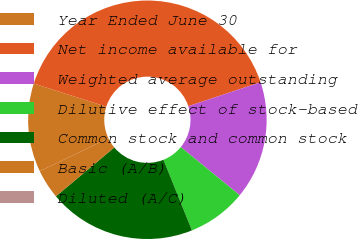<chart> <loc_0><loc_0><loc_500><loc_500><pie_chart><fcel>Year Ended June 30<fcel>Net income available for<fcel>Weighted average outstanding<fcel>Dilutive effect of stock-based<fcel>Common stock and common stock<fcel>Basic (A/B)<fcel>Diluted (A/C)<nl><fcel>12.0%<fcel>39.99%<fcel>16.0%<fcel>8.0%<fcel>20.0%<fcel>4.0%<fcel>0.0%<nl></chart> 